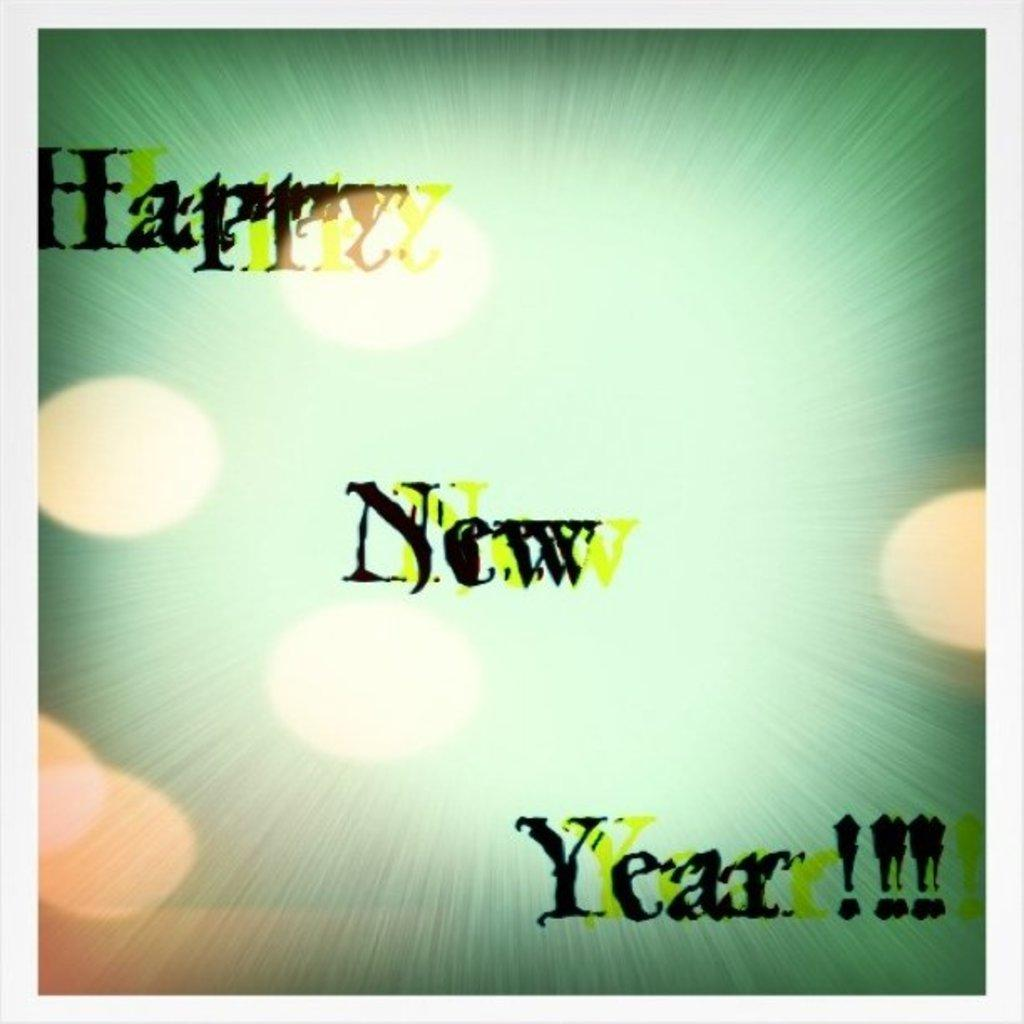<image>
Describe the image concisely. A card for Happy New Year with a green background and yellow dots. 